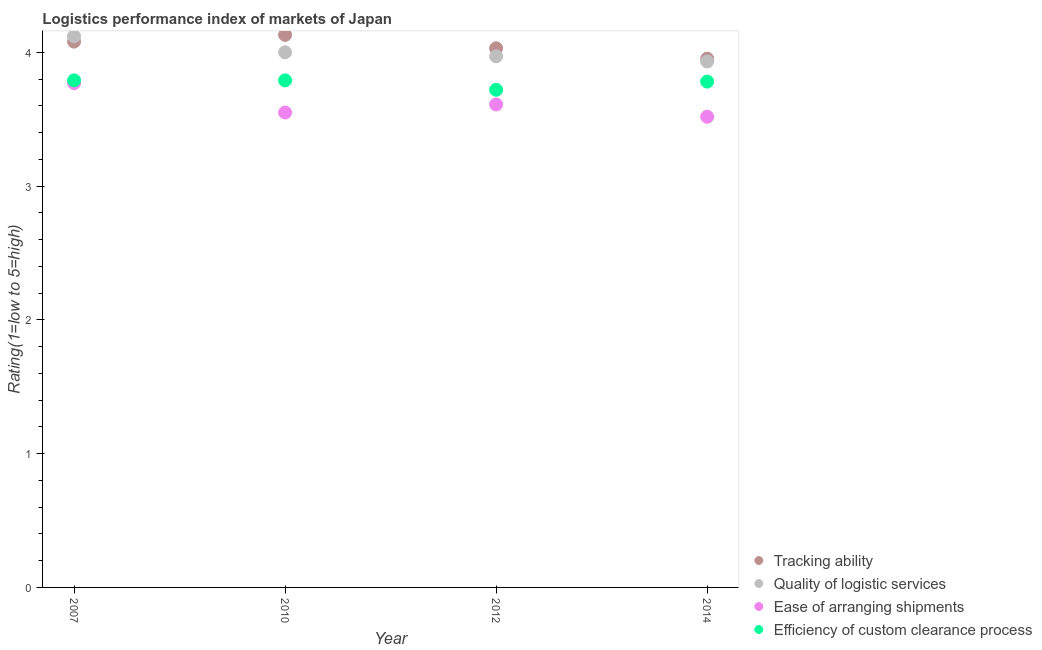What is the lpi rating of tracking ability in 2007?
Ensure brevity in your answer.  4.08. Across all years, what is the maximum lpi rating of quality of logistic services?
Provide a short and direct response. 4.12. Across all years, what is the minimum lpi rating of efficiency of custom clearance process?
Ensure brevity in your answer.  3.72. In which year was the lpi rating of ease of arranging shipments maximum?
Offer a terse response. 2007. In which year was the lpi rating of tracking ability minimum?
Provide a succinct answer. 2014. What is the total lpi rating of quality of logistic services in the graph?
Provide a succinct answer. 16.02. What is the difference between the lpi rating of ease of arranging shipments in 2010 and that in 2014?
Keep it short and to the point. 0.03. What is the difference between the lpi rating of ease of arranging shipments in 2014 and the lpi rating of tracking ability in 2012?
Your answer should be very brief. -0.51. What is the average lpi rating of ease of arranging shipments per year?
Offer a terse response. 3.61. In the year 2014, what is the difference between the lpi rating of efficiency of custom clearance process and lpi rating of tracking ability?
Make the answer very short. -0.17. In how many years, is the lpi rating of tracking ability greater than 2.6?
Provide a succinct answer. 4. What is the ratio of the lpi rating of quality of logistic services in 2007 to that in 2010?
Provide a succinct answer. 1.03. Is the lpi rating of ease of arranging shipments in 2010 less than that in 2014?
Offer a terse response. No. What is the difference between the highest and the second highest lpi rating of ease of arranging shipments?
Ensure brevity in your answer.  0.16. What is the difference between the highest and the lowest lpi rating of ease of arranging shipments?
Make the answer very short. 0.25. Is the sum of the lpi rating of ease of arranging shipments in 2007 and 2014 greater than the maximum lpi rating of quality of logistic services across all years?
Ensure brevity in your answer.  Yes. Is it the case that in every year, the sum of the lpi rating of tracking ability and lpi rating of quality of logistic services is greater than the sum of lpi rating of efficiency of custom clearance process and lpi rating of ease of arranging shipments?
Your answer should be very brief. No. Is it the case that in every year, the sum of the lpi rating of tracking ability and lpi rating of quality of logistic services is greater than the lpi rating of ease of arranging shipments?
Keep it short and to the point. Yes. Does the lpi rating of ease of arranging shipments monotonically increase over the years?
Make the answer very short. No. Is the lpi rating of quality of logistic services strictly greater than the lpi rating of efficiency of custom clearance process over the years?
Offer a very short reply. Yes. How many years are there in the graph?
Make the answer very short. 4. Where does the legend appear in the graph?
Offer a terse response. Bottom right. What is the title of the graph?
Provide a short and direct response. Logistics performance index of markets of Japan. What is the label or title of the Y-axis?
Ensure brevity in your answer.  Rating(1=low to 5=high). What is the Rating(1=low to 5=high) in Tracking ability in 2007?
Offer a very short reply. 4.08. What is the Rating(1=low to 5=high) in Quality of logistic services in 2007?
Your response must be concise. 4.12. What is the Rating(1=low to 5=high) of Ease of arranging shipments in 2007?
Keep it short and to the point. 3.77. What is the Rating(1=low to 5=high) in Efficiency of custom clearance process in 2007?
Ensure brevity in your answer.  3.79. What is the Rating(1=low to 5=high) in Tracking ability in 2010?
Ensure brevity in your answer.  4.13. What is the Rating(1=low to 5=high) in Ease of arranging shipments in 2010?
Provide a short and direct response. 3.55. What is the Rating(1=low to 5=high) in Efficiency of custom clearance process in 2010?
Make the answer very short. 3.79. What is the Rating(1=low to 5=high) in Tracking ability in 2012?
Ensure brevity in your answer.  4.03. What is the Rating(1=low to 5=high) in Quality of logistic services in 2012?
Your response must be concise. 3.97. What is the Rating(1=low to 5=high) of Ease of arranging shipments in 2012?
Provide a short and direct response. 3.61. What is the Rating(1=low to 5=high) of Efficiency of custom clearance process in 2012?
Make the answer very short. 3.72. What is the Rating(1=low to 5=high) in Tracking ability in 2014?
Ensure brevity in your answer.  3.95. What is the Rating(1=low to 5=high) of Quality of logistic services in 2014?
Ensure brevity in your answer.  3.93. What is the Rating(1=low to 5=high) in Ease of arranging shipments in 2014?
Your answer should be very brief. 3.52. What is the Rating(1=low to 5=high) of Efficiency of custom clearance process in 2014?
Provide a short and direct response. 3.78. Across all years, what is the maximum Rating(1=low to 5=high) in Tracking ability?
Provide a short and direct response. 4.13. Across all years, what is the maximum Rating(1=low to 5=high) of Quality of logistic services?
Make the answer very short. 4.12. Across all years, what is the maximum Rating(1=low to 5=high) of Ease of arranging shipments?
Give a very brief answer. 3.77. Across all years, what is the maximum Rating(1=low to 5=high) in Efficiency of custom clearance process?
Offer a very short reply. 3.79. Across all years, what is the minimum Rating(1=low to 5=high) of Tracking ability?
Provide a succinct answer. 3.95. Across all years, what is the minimum Rating(1=low to 5=high) in Quality of logistic services?
Your response must be concise. 3.93. Across all years, what is the minimum Rating(1=low to 5=high) of Ease of arranging shipments?
Provide a short and direct response. 3.52. Across all years, what is the minimum Rating(1=low to 5=high) in Efficiency of custom clearance process?
Offer a very short reply. 3.72. What is the total Rating(1=low to 5=high) of Tracking ability in the graph?
Your answer should be compact. 16.19. What is the total Rating(1=low to 5=high) in Quality of logistic services in the graph?
Offer a terse response. 16.02. What is the total Rating(1=low to 5=high) of Ease of arranging shipments in the graph?
Keep it short and to the point. 14.45. What is the total Rating(1=low to 5=high) of Efficiency of custom clearance process in the graph?
Keep it short and to the point. 15.08. What is the difference between the Rating(1=low to 5=high) of Quality of logistic services in 2007 and that in 2010?
Make the answer very short. 0.12. What is the difference between the Rating(1=low to 5=high) in Ease of arranging shipments in 2007 and that in 2010?
Offer a very short reply. 0.22. What is the difference between the Rating(1=low to 5=high) in Tracking ability in 2007 and that in 2012?
Offer a very short reply. 0.05. What is the difference between the Rating(1=low to 5=high) of Ease of arranging shipments in 2007 and that in 2012?
Provide a succinct answer. 0.16. What is the difference between the Rating(1=low to 5=high) in Efficiency of custom clearance process in 2007 and that in 2012?
Your answer should be compact. 0.07. What is the difference between the Rating(1=low to 5=high) of Tracking ability in 2007 and that in 2014?
Ensure brevity in your answer.  0.13. What is the difference between the Rating(1=low to 5=high) of Quality of logistic services in 2007 and that in 2014?
Offer a very short reply. 0.19. What is the difference between the Rating(1=low to 5=high) of Ease of arranging shipments in 2007 and that in 2014?
Offer a terse response. 0.25. What is the difference between the Rating(1=low to 5=high) of Efficiency of custom clearance process in 2007 and that in 2014?
Offer a terse response. 0.01. What is the difference between the Rating(1=low to 5=high) of Quality of logistic services in 2010 and that in 2012?
Make the answer very short. 0.03. What is the difference between the Rating(1=low to 5=high) in Ease of arranging shipments in 2010 and that in 2012?
Make the answer very short. -0.06. What is the difference between the Rating(1=low to 5=high) in Efficiency of custom clearance process in 2010 and that in 2012?
Provide a short and direct response. 0.07. What is the difference between the Rating(1=low to 5=high) of Tracking ability in 2010 and that in 2014?
Your answer should be compact. 0.18. What is the difference between the Rating(1=low to 5=high) in Quality of logistic services in 2010 and that in 2014?
Make the answer very short. 0.07. What is the difference between the Rating(1=low to 5=high) in Ease of arranging shipments in 2010 and that in 2014?
Provide a short and direct response. 0.03. What is the difference between the Rating(1=low to 5=high) of Efficiency of custom clearance process in 2010 and that in 2014?
Provide a short and direct response. 0.01. What is the difference between the Rating(1=low to 5=high) of Tracking ability in 2012 and that in 2014?
Provide a short and direct response. 0.08. What is the difference between the Rating(1=low to 5=high) in Quality of logistic services in 2012 and that in 2014?
Offer a terse response. 0.04. What is the difference between the Rating(1=low to 5=high) in Ease of arranging shipments in 2012 and that in 2014?
Make the answer very short. 0.09. What is the difference between the Rating(1=low to 5=high) in Efficiency of custom clearance process in 2012 and that in 2014?
Your response must be concise. -0.06. What is the difference between the Rating(1=low to 5=high) in Tracking ability in 2007 and the Rating(1=low to 5=high) in Quality of logistic services in 2010?
Offer a terse response. 0.08. What is the difference between the Rating(1=low to 5=high) of Tracking ability in 2007 and the Rating(1=low to 5=high) of Ease of arranging shipments in 2010?
Your answer should be very brief. 0.53. What is the difference between the Rating(1=low to 5=high) in Tracking ability in 2007 and the Rating(1=low to 5=high) in Efficiency of custom clearance process in 2010?
Your response must be concise. 0.29. What is the difference between the Rating(1=low to 5=high) of Quality of logistic services in 2007 and the Rating(1=low to 5=high) of Ease of arranging shipments in 2010?
Offer a terse response. 0.57. What is the difference between the Rating(1=low to 5=high) of Quality of logistic services in 2007 and the Rating(1=low to 5=high) of Efficiency of custom clearance process in 2010?
Provide a short and direct response. 0.33. What is the difference between the Rating(1=low to 5=high) of Ease of arranging shipments in 2007 and the Rating(1=low to 5=high) of Efficiency of custom clearance process in 2010?
Make the answer very short. -0.02. What is the difference between the Rating(1=low to 5=high) in Tracking ability in 2007 and the Rating(1=low to 5=high) in Quality of logistic services in 2012?
Make the answer very short. 0.11. What is the difference between the Rating(1=low to 5=high) in Tracking ability in 2007 and the Rating(1=low to 5=high) in Ease of arranging shipments in 2012?
Your answer should be compact. 0.47. What is the difference between the Rating(1=low to 5=high) of Tracking ability in 2007 and the Rating(1=low to 5=high) of Efficiency of custom clearance process in 2012?
Your response must be concise. 0.36. What is the difference between the Rating(1=low to 5=high) in Quality of logistic services in 2007 and the Rating(1=low to 5=high) in Ease of arranging shipments in 2012?
Make the answer very short. 0.51. What is the difference between the Rating(1=low to 5=high) of Quality of logistic services in 2007 and the Rating(1=low to 5=high) of Efficiency of custom clearance process in 2012?
Ensure brevity in your answer.  0.4. What is the difference between the Rating(1=low to 5=high) of Tracking ability in 2007 and the Rating(1=low to 5=high) of Quality of logistic services in 2014?
Your answer should be very brief. 0.15. What is the difference between the Rating(1=low to 5=high) in Tracking ability in 2007 and the Rating(1=low to 5=high) in Ease of arranging shipments in 2014?
Your response must be concise. 0.56. What is the difference between the Rating(1=low to 5=high) in Tracking ability in 2007 and the Rating(1=low to 5=high) in Efficiency of custom clearance process in 2014?
Make the answer very short. 0.3. What is the difference between the Rating(1=low to 5=high) in Quality of logistic services in 2007 and the Rating(1=low to 5=high) in Ease of arranging shipments in 2014?
Offer a terse response. 0.6. What is the difference between the Rating(1=low to 5=high) in Quality of logistic services in 2007 and the Rating(1=low to 5=high) in Efficiency of custom clearance process in 2014?
Give a very brief answer. 0.34. What is the difference between the Rating(1=low to 5=high) in Ease of arranging shipments in 2007 and the Rating(1=low to 5=high) in Efficiency of custom clearance process in 2014?
Offer a very short reply. -0.01. What is the difference between the Rating(1=low to 5=high) in Tracking ability in 2010 and the Rating(1=low to 5=high) in Quality of logistic services in 2012?
Make the answer very short. 0.16. What is the difference between the Rating(1=low to 5=high) in Tracking ability in 2010 and the Rating(1=low to 5=high) in Ease of arranging shipments in 2012?
Give a very brief answer. 0.52. What is the difference between the Rating(1=low to 5=high) of Tracking ability in 2010 and the Rating(1=low to 5=high) of Efficiency of custom clearance process in 2012?
Keep it short and to the point. 0.41. What is the difference between the Rating(1=low to 5=high) of Quality of logistic services in 2010 and the Rating(1=low to 5=high) of Ease of arranging shipments in 2012?
Your response must be concise. 0.39. What is the difference between the Rating(1=low to 5=high) in Quality of logistic services in 2010 and the Rating(1=low to 5=high) in Efficiency of custom clearance process in 2012?
Your answer should be very brief. 0.28. What is the difference between the Rating(1=low to 5=high) of Ease of arranging shipments in 2010 and the Rating(1=low to 5=high) of Efficiency of custom clearance process in 2012?
Make the answer very short. -0.17. What is the difference between the Rating(1=low to 5=high) of Tracking ability in 2010 and the Rating(1=low to 5=high) of Quality of logistic services in 2014?
Your answer should be compact. 0.2. What is the difference between the Rating(1=low to 5=high) in Tracking ability in 2010 and the Rating(1=low to 5=high) in Ease of arranging shipments in 2014?
Your answer should be very brief. 0.61. What is the difference between the Rating(1=low to 5=high) in Tracking ability in 2010 and the Rating(1=low to 5=high) in Efficiency of custom clearance process in 2014?
Give a very brief answer. 0.35. What is the difference between the Rating(1=low to 5=high) in Quality of logistic services in 2010 and the Rating(1=low to 5=high) in Ease of arranging shipments in 2014?
Give a very brief answer. 0.48. What is the difference between the Rating(1=low to 5=high) in Quality of logistic services in 2010 and the Rating(1=low to 5=high) in Efficiency of custom clearance process in 2014?
Offer a terse response. 0.22. What is the difference between the Rating(1=low to 5=high) of Ease of arranging shipments in 2010 and the Rating(1=low to 5=high) of Efficiency of custom clearance process in 2014?
Your answer should be compact. -0.23. What is the difference between the Rating(1=low to 5=high) in Tracking ability in 2012 and the Rating(1=low to 5=high) in Quality of logistic services in 2014?
Ensure brevity in your answer.  0.1. What is the difference between the Rating(1=low to 5=high) in Tracking ability in 2012 and the Rating(1=low to 5=high) in Ease of arranging shipments in 2014?
Your answer should be very brief. 0.51. What is the difference between the Rating(1=low to 5=high) in Tracking ability in 2012 and the Rating(1=low to 5=high) in Efficiency of custom clearance process in 2014?
Provide a short and direct response. 0.25. What is the difference between the Rating(1=low to 5=high) in Quality of logistic services in 2012 and the Rating(1=low to 5=high) in Ease of arranging shipments in 2014?
Your answer should be compact. 0.45. What is the difference between the Rating(1=low to 5=high) of Quality of logistic services in 2012 and the Rating(1=low to 5=high) of Efficiency of custom clearance process in 2014?
Provide a short and direct response. 0.19. What is the difference between the Rating(1=low to 5=high) in Ease of arranging shipments in 2012 and the Rating(1=low to 5=high) in Efficiency of custom clearance process in 2014?
Your response must be concise. -0.17. What is the average Rating(1=low to 5=high) of Tracking ability per year?
Your answer should be very brief. 4.05. What is the average Rating(1=low to 5=high) of Quality of logistic services per year?
Ensure brevity in your answer.  4.01. What is the average Rating(1=low to 5=high) in Ease of arranging shipments per year?
Keep it short and to the point. 3.61. What is the average Rating(1=low to 5=high) of Efficiency of custom clearance process per year?
Your answer should be compact. 3.77. In the year 2007, what is the difference between the Rating(1=low to 5=high) of Tracking ability and Rating(1=low to 5=high) of Quality of logistic services?
Your answer should be compact. -0.04. In the year 2007, what is the difference between the Rating(1=low to 5=high) of Tracking ability and Rating(1=low to 5=high) of Ease of arranging shipments?
Keep it short and to the point. 0.31. In the year 2007, what is the difference between the Rating(1=low to 5=high) of Tracking ability and Rating(1=low to 5=high) of Efficiency of custom clearance process?
Make the answer very short. 0.29. In the year 2007, what is the difference between the Rating(1=low to 5=high) in Quality of logistic services and Rating(1=low to 5=high) in Ease of arranging shipments?
Your answer should be very brief. 0.35. In the year 2007, what is the difference between the Rating(1=low to 5=high) of Quality of logistic services and Rating(1=low to 5=high) of Efficiency of custom clearance process?
Your answer should be compact. 0.33. In the year 2007, what is the difference between the Rating(1=low to 5=high) in Ease of arranging shipments and Rating(1=low to 5=high) in Efficiency of custom clearance process?
Offer a very short reply. -0.02. In the year 2010, what is the difference between the Rating(1=low to 5=high) in Tracking ability and Rating(1=low to 5=high) in Quality of logistic services?
Provide a succinct answer. 0.13. In the year 2010, what is the difference between the Rating(1=low to 5=high) in Tracking ability and Rating(1=low to 5=high) in Ease of arranging shipments?
Your answer should be very brief. 0.58. In the year 2010, what is the difference between the Rating(1=low to 5=high) in Tracking ability and Rating(1=low to 5=high) in Efficiency of custom clearance process?
Give a very brief answer. 0.34. In the year 2010, what is the difference between the Rating(1=low to 5=high) in Quality of logistic services and Rating(1=low to 5=high) in Ease of arranging shipments?
Your answer should be compact. 0.45. In the year 2010, what is the difference between the Rating(1=low to 5=high) of Quality of logistic services and Rating(1=low to 5=high) of Efficiency of custom clearance process?
Give a very brief answer. 0.21. In the year 2010, what is the difference between the Rating(1=low to 5=high) in Ease of arranging shipments and Rating(1=low to 5=high) in Efficiency of custom clearance process?
Keep it short and to the point. -0.24. In the year 2012, what is the difference between the Rating(1=low to 5=high) of Tracking ability and Rating(1=low to 5=high) of Quality of logistic services?
Give a very brief answer. 0.06. In the year 2012, what is the difference between the Rating(1=low to 5=high) in Tracking ability and Rating(1=low to 5=high) in Ease of arranging shipments?
Your response must be concise. 0.42. In the year 2012, what is the difference between the Rating(1=low to 5=high) of Tracking ability and Rating(1=low to 5=high) of Efficiency of custom clearance process?
Give a very brief answer. 0.31. In the year 2012, what is the difference between the Rating(1=low to 5=high) of Quality of logistic services and Rating(1=low to 5=high) of Ease of arranging shipments?
Ensure brevity in your answer.  0.36. In the year 2012, what is the difference between the Rating(1=low to 5=high) of Ease of arranging shipments and Rating(1=low to 5=high) of Efficiency of custom clearance process?
Your response must be concise. -0.11. In the year 2014, what is the difference between the Rating(1=low to 5=high) of Tracking ability and Rating(1=low to 5=high) of Quality of logistic services?
Give a very brief answer. 0.02. In the year 2014, what is the difference between the Rating(1=low to 5=high) in Tracking ability and Rating(1=low to 5=high) in Ease of arranging shipments?
Keep it short and to the point. 0.43. In the year 2014, what is the difference between the Rating(1=low to 5=high) in Tracking ability and Rating(1=low to 5=high) in Efficiency of custom clearance process?
Keep it short and to the point. 0.17. In the year 2014, what is the difference between the Rating(1=low to 5=high) of Quality of logistic services and Rating(1=low to 5=high) of Ease of arranging shipments?
Offer a very short reply. 0.41. In the year 2014, what is the difference between the Rating(1=low to 5=high) in Quality of logistic services and Rating(1=low to 5=high) in Efficiency of custom clearance process?
Make the answer very short. 0.15. In the year 2014, what is the difference between the Rating(1=low to 5=high) in Ease of arranging shipments and Rating(1=low to 5=high) in Efficiency of custom clearance process?
Your answer should be compact. -0.26. What is the ratio of the Rating(1=low to 5=high) in Tracking ability in 2007 to that in 2010?
Provide a succinct answer. 0.99. What is the ratio of the Rating(1=low to 5=high) in Ease of arranging shipments in 2007 to that in 2010?
Your answer should be very brief. 1.06. What is the ratio of the Rating(1=low to 5=high) of Tracking ability in 2007 to that in 2012?
Offer a terse response. 1.01. What is the ratio of the Rating(1=low to 5=high) of Quality of logistic services in 2007 to that in 2012?
Offer a very short reply. 1.04. What is the ratio of the Rating(1=low to 5=high) in Ease of arranging shipments in 2007 to that in 2012?
Provide a succinct answer. 1.04. What is the ratio of the Rating(1=low to 5=high) in Efficiency of custom clearance process in 2007 to that in 2012?
Offer a very short reply. 1.02. What is the ratio of the Rating(1=low to 5=high) of Tracking ability in 2007 to that in 2014?
Offer a very short reply. 1.03. What is the ratio of the Rating(1=low to 5=high) in Quality of logistic services in 2007 to that in 2014?
Offer a terse response. 1.05. What is the ratio of the Rating(1=low to 5=high) in Ease of arranging shipments in 2007 to that in 2014?
Provide a short and direct response. 1.07. What is the ratio of the Rating(1=low to 5=high) of Tracking ability in 2010 to that in 2012?
Make the answer very short. 1.02. What is the ratio of the Rating(1=low to 5=high) in Quality of logistic services in 2010 to that in 2012?
Give a very brief answer. 1.01. What is the ratio of the Rating(1=low to 5=high) of Ease of arranging shipments in 2010 to that in 2012?
Your response must be concise. 0.98. What is the ratio of the Rating(1=low to 5=high) of Efficiency of custom clearance process in 2010 to that in 2012?
Offer a terse response. 1.02. What is the ratio of the Rating(1=low to 5=high) in Tracking ability in 2010 to that in 2014?
Make the answer very short. 1.04. What is the ratio of the Rating(1=low to 5=high) in Quality of logistic services in 2010 to that in 2014?
Give a very brief answer. 1.02. What is the ratio of the Rating(1=low to 5=high) of Tracking ability in 2012 to that in 2014?
Offer a very short reply. 1.02. What is the ratio of the Rating(1=low to 5=high) of Quality of logistic services in 2012 to that in 2014?
Your response must be concise. 1.01. What is the ratio of the Rating(1=low to 5=high) of Efficiency of custom clearance process in 2012 to that in 2014?
Offer a terse response. 0.98. What is the difference between the highest and the second highest Rating(1=low to 5=high) of Tracking ability?
Your answer should be very brief. 0.05. What is the difference between the highest and the second highest Rating(1=low to 5=high) in Quality of logistic services?
Offer a terse response. 0.12. What is the difference between the highest and the second highest Rating(1=low to 5=high) of Ease of arranging shipments?
Offer a terse response. 0.16. What is the difference between the highest and the lowest Rating(1=low to 5=high) in Tracking ability?
Your answer should be compact. 0.18. What is the difference between the highest and the lowest Rating(1=low to 5=high) in Quality of logistic services?
Provide a short and direct response. 0.19. What is the difference between the highest and the lowest Rating(1=low to 5=high) in Ease of arranging shipments?
Your response must be concise. 0.25. What is the difference between the highest and the lowest Rating(1=low to 5=high) in Efficiency of custom clearance process?
Provide a succinct answer. 0.07. 